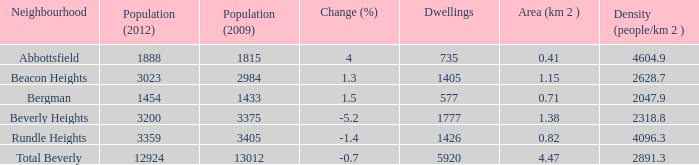How many Dwellings does Beverly Heights have that have a change percent larger than -5.2? None. 